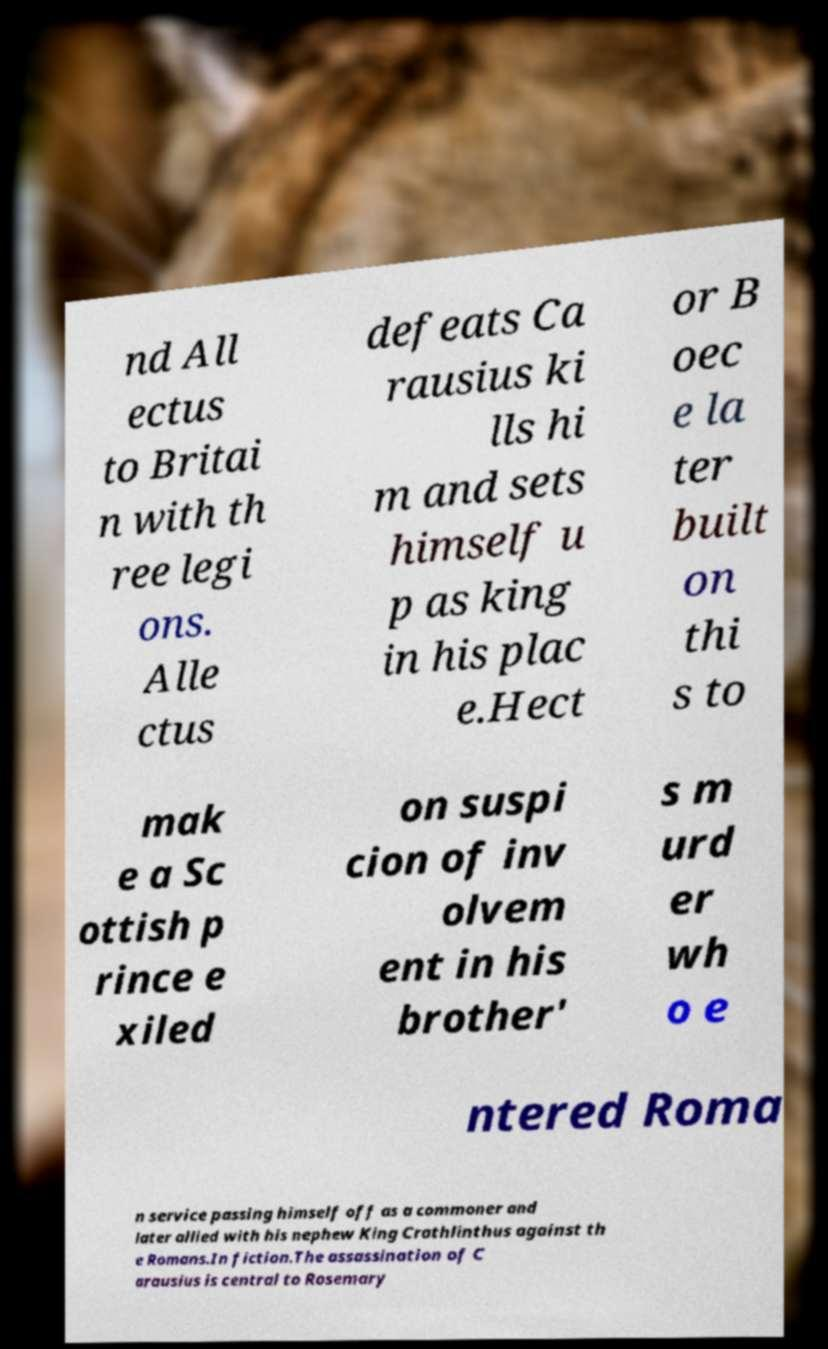Can you accurately transcribe the text from the provided image for me? nd All ectus to Britai n with th ree legi ons. Alle ctus defeats Ca rausius ki lls hi m and sets himself u p as king in his plac e.Hect or B oec e la ter built on thi s to mak e a Sc ottish p rince e xiled on suspi cion of inv olvem ent in his brother' s m urd er wh o e ntered Roma n service passing himself off as a commoner and later allied with his nephew King Crathlinthus against th e Romans.In fiction.The assassination of C arausius is central to Rosemary 